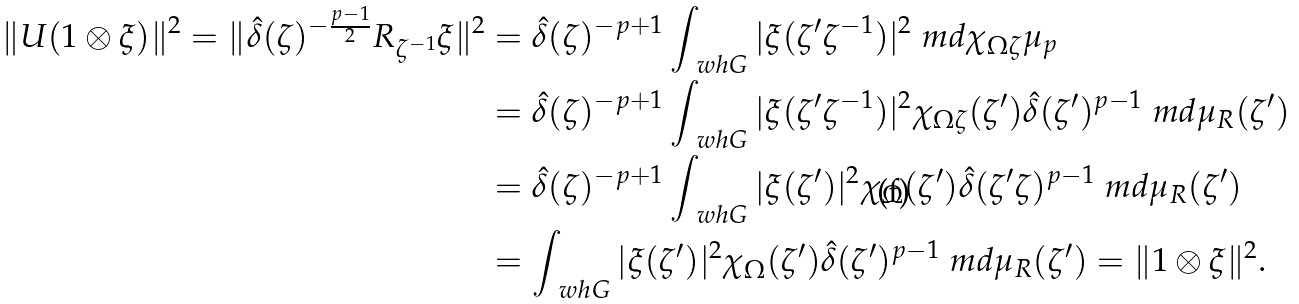Convert formula to latex. <formula><loc_0><loc_0><loc_500><loc_500>\| U ( 1 \otimes \xi ) \| ^ { 2 } = \| \hat { \delta } ( \zeta ) ^ { - \frac { p - 1 } { 2 } } R _ { \zeta ^ { - 1 } } \xi \| ^ { 2 } & = \hat { \delta } ( \zeta ) ^ { - p + 1 } \int _ { \ w h G } | \xi ( \zeta ^ { \prime } \zeta ^ { - 1 } ) | ^ { 2 } \ m d \chi _ { \Omega \zeta } \mu _ { p } \\ & = \hat { \delta } ( \zeta ) ^ { - p + 1 } \int _ { \ w h G } | \xi ( \zeta ^ { \prime } \zeta ^ { - 1 } ) | ^ { 2 } \chi _ { \Omega \zeta } ( \zeta ^ { \prime } ) \hat { \delta } ( \zeta ^ { \prime } ) ^ { p - 1 } \ m d \mu _ { R } ( \zeta ^ { \prime } ) \\ & = \hat { \delta } ( \zeta ) ^ { - p + 1 } \int _ { \ w h G } | \xi ( \zeta ^ { \prime } ) | ^ { 2 } \chi _ { \Omega } ( \zeta ^ { \prime } ) \hat { \delta } ( \zeta ^ { \prime } \zeta ) ^ { p - 1 } \ m d \mu _ { R } ( \zeta ^ { \prime } ) \\ & = \int _ { \ w h G } | \xi ( \zeta ^ { \prime } ) | ^ { 2 } \chi _ { \Omega } ( \zeta ^ { \prime } ) \hat { \delta } ( \zeta ^ { \prime } ) ^ { p - 1 } \ m d \mu _ { R } ( \zeta ^ { \prime } ) = \| 1 \otimes \xi \| ^ { 2 } .</formula> 